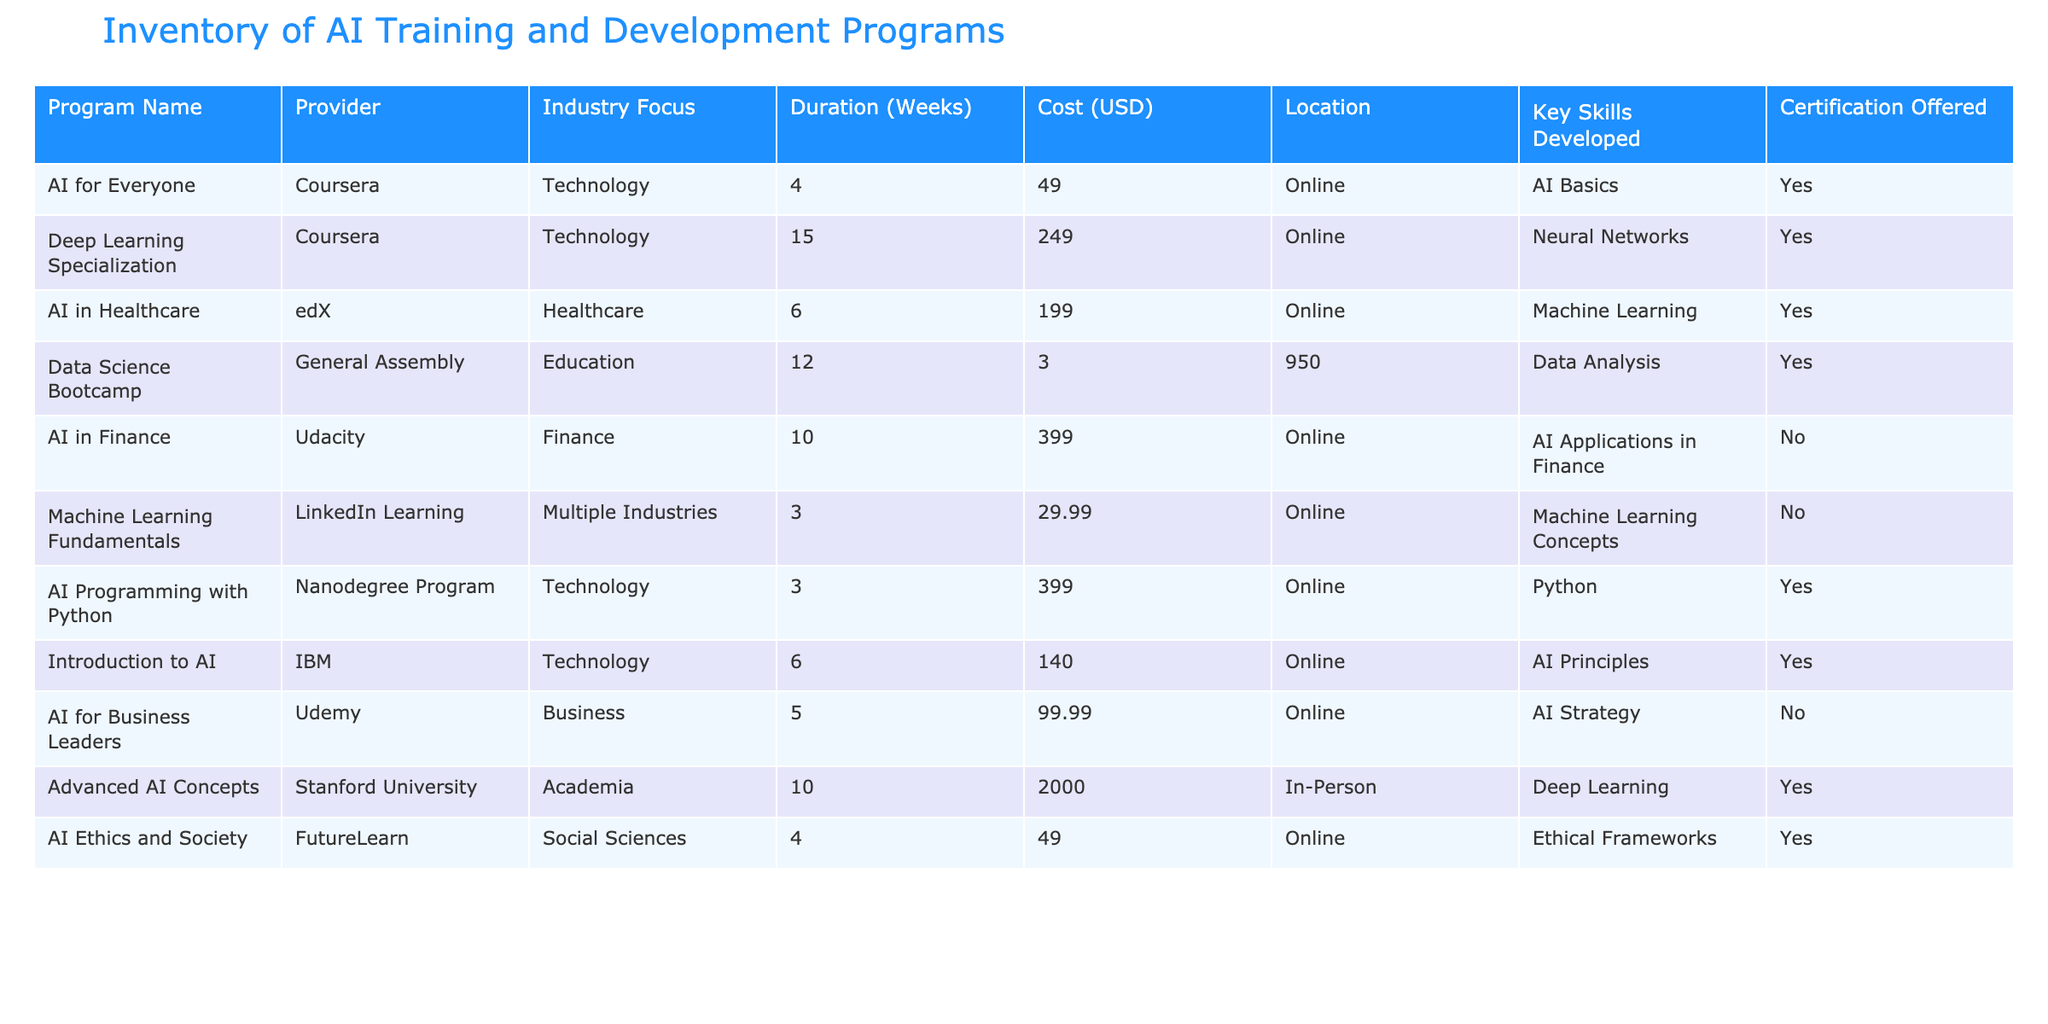What is the cost of the Data Science Bootcamp? The entry for the Data Science Bootcamp under the Cost (USD) column shows 3,950.
Answer: 3,950 How many weeks does the AI in Healthcare program last? The Duration (Weeks) column for the AI in Healthcare program indicates it lasts for 6 weeks.
Answer: 6 Which program offers a certification? By reviewing the Certification Offered column, we can see that the programs AI for Everyone, Deep Learning Specialization, AI in Healthcare, Data Science Bootcamp, AI Programming with Python, Introduction to AI, AI Ethics and Society offer certification.
Answer: AI for Everyone, Deep Learning Specialization, AI in Healthcare, Data Science Bootcamp, AI Programming with Python, Introduction to AI, AI Ethics and Society What is the average duration of all programs listed? To find the average, we sum the durations of each program (4 + 15 + 6 + 12 + 10 + 3 + 3 + 6 + 5 + 10 + 4) which equals 78. There are 11 programs, so we divide 78 by 11 which gives an average of approximately 7.09 weeks.
Answer: 7.09 Is there any program that focuses on both technology and offers certification? We check the Industry Focus and Certification Offered columns. The programs AI for Everyone, Deep Learning Specialization, AI Programming with Python, and Introduction to AI focus on technology and all offer certification.
Answer: Yes What is the total cost of the programs that focus on Healthcare and offer certification? First, we identify the programs focusing on Healthcare that offer certification, which is AI in Healthcare costing 199. There is only one program in this category, so the total cost is 199.
Answer: 199 How many training programs are offered online? By reviewing the Location column, we find that all programs except the Advanced AI Concepts program are listed as online. There are 10 programs in total, and only 1 is in-person, so that means 10 are online.
Answer: 10 Are there any programs that focus on Business and also offer a certification? Checking the Industry Focus and the Certification Offered columns, we find that the AI for Business Leaders program focuses on Business but does not offer certification. Thus, there are no programs that meet both criteria.
Answer: No 